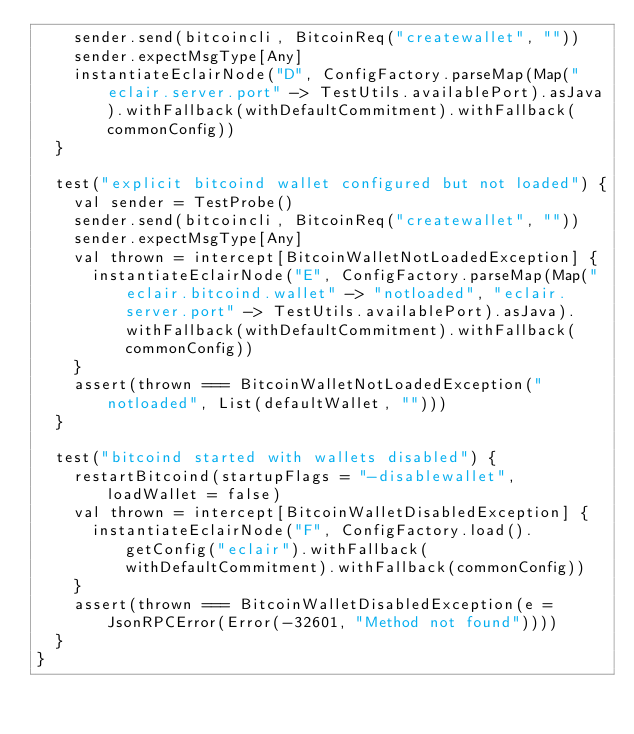<code> <loc_0><loc_0><loc_500><loc_500><_Scala_>    sender.send(bitcoincli, BitcoinReq("createwallet", ""))
    sender.expectMsgType[Any]
    instantiateEclairNode("D", ConfigFactory.parseMap(Map("eclair.server.port" -> TestUtils.availablePort).asJava).withFallback(withDefaultCommitment).withFallback(commonConfig))
  }

  test("explicit bitcoind wallet configured but not loaded") {
    val sender = TestProbe()
    sender.send(bitcoincli, BitcoinReq("createwallet", ""))
    sender.expectMsgType[Any]
    val thrown = intercept[BitcoinWalletNotLoadedException] {
      instantiateEclairNode("E", ConfigFactory.parseMap(Map("eclair.bitcoind.wallet" -> "notloaded", "eclair.server.port" -> TestUtils.availablePort).asJava).withFallback(withDefaultCommitment).withFallback(commonConfig))
    }
    assert(thrown === BitcoinWalletNotLoadedException("notloaded", List(defaultWallet, "")))
  }

  test("bitcoind started with wallets disabled") {
    restartBitcoind(startupFlags = "-disablewallet", loadWallet = false)
    val thrown = intercept[BitcoinWalletDisabledException] {
      instantiateEclairNode("F", ConfigFactory.load().getConfig("eclair").withFallback(withDefaultCommitment).withFallback(commonConfig))
    }
    assert(thrown === BitcoinWalletDisabledException(e = JsonRPCError(Error(-32601, "Method not found"))))
  }
}</code> 